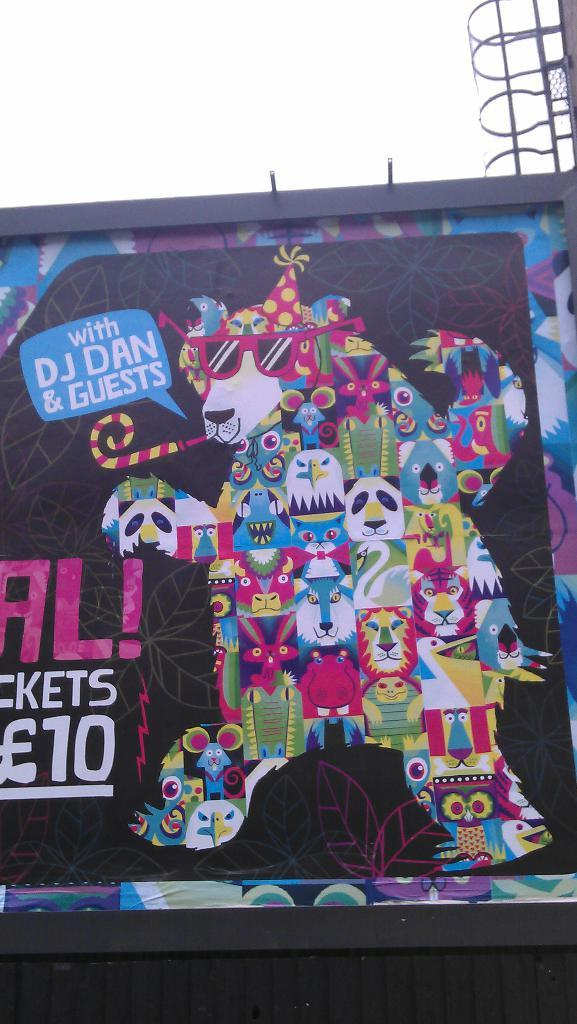What is the main subject of the image? The main subject of the image is a painting on the wall. Can you describe the painting? The painting has text written on it. What else can be seen on the right side of the image? There is a stand on the right side of the image. What type of advertisement is displayed on the painting? There is no advertisement present on the painting; it is a painting with text written on it. 